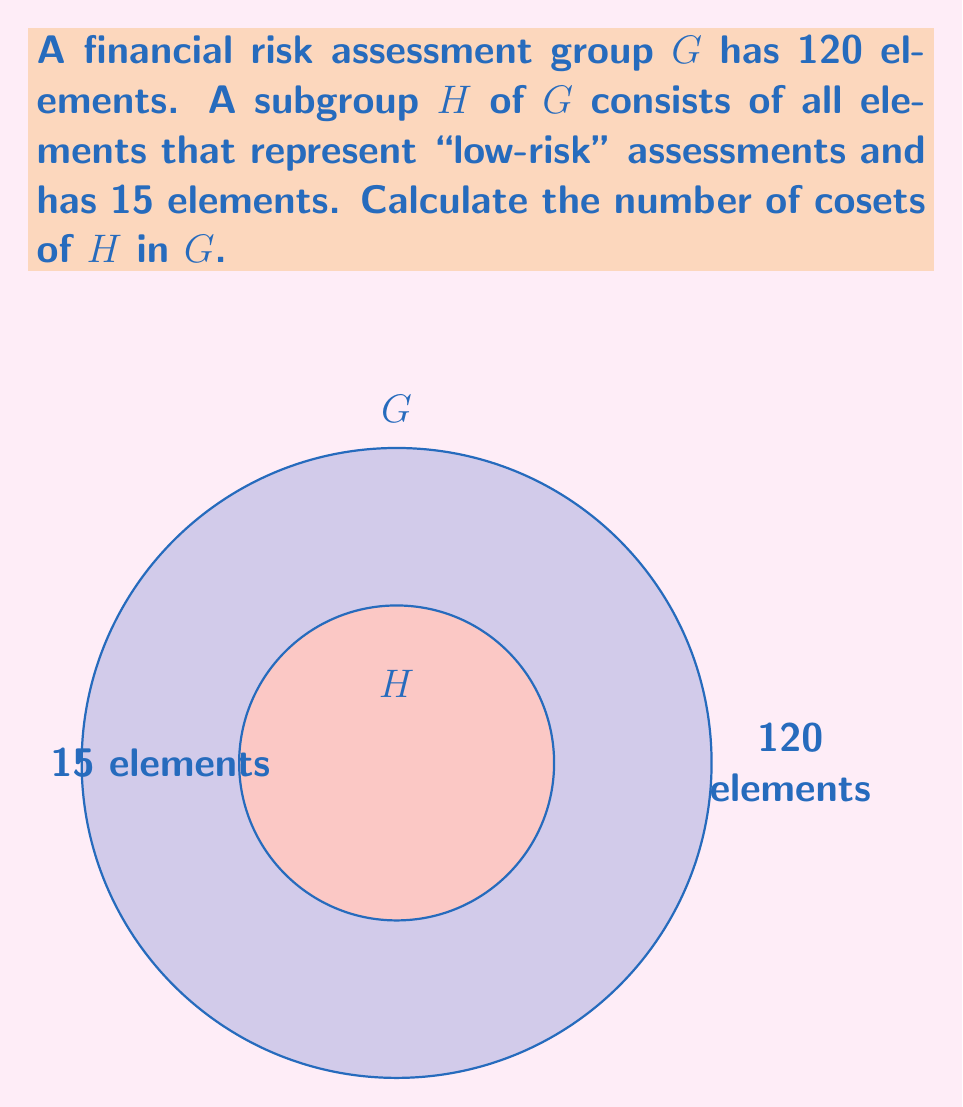Help me with this question. To find the number of cosets of H in G, we can use Lagrange's theorem, which states that for a finite group G and a subgroup H of G:

$$|G| = |H| \cdot [G:H]$$

Where:
- $|G|$ is the order (number of elements) of group G
- $|H|$ is the order of subgroup H
- $[G:H]$ is the index of H in G, which represents the number of cosets of H in G

We are given:
- $|G| = 120$ (the financial risk assessment group has 120 elements)
- $|H| = 15$ (the low-risk subgroup has 15 elements)

To find $[G:H]$, we rearrange Lagrange's theorem:

$$[G:H] = \frac{|G|}{|H|}$$

Substituting the values:

$$[G:H] = \frac{120}{15}$$

Simplifying:

$$[G:H] = 8$$

Therefore, there are 8 cosets of H in G.
Answer: 8 cosets 